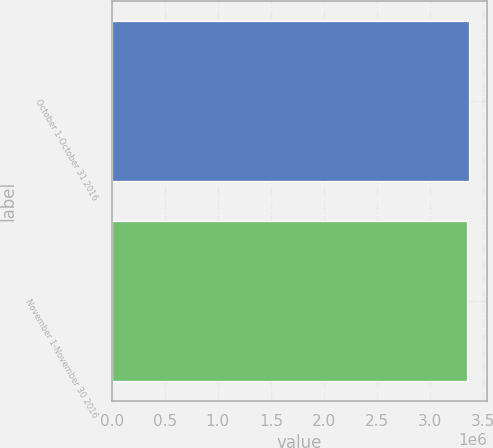Convert chart to OTSL. <chart><loc_0><loc_0><loc_500><loc_500><bar_chart><fcel>October 1-October 31 2016<fcel>November 1-November 30 2016<nl><fcel>3.36702e+06<fcel>3.35163e+06<nl></chart> 